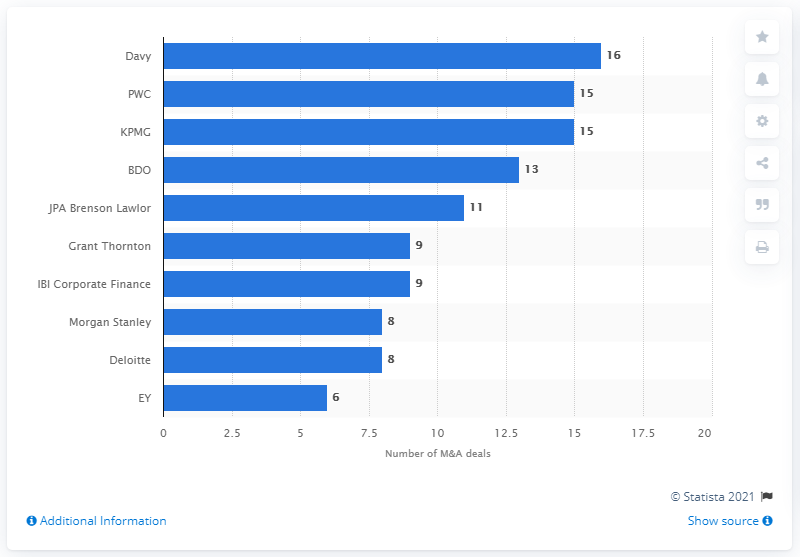Give some essential details in this illustration. In 2020, Davy advised on a total of 16 deals. PwC and KPMG had a total of 15 deals in 2020. Davy was the leading financial advisor for merger and acquisition transactions in Ireland in 2020. 